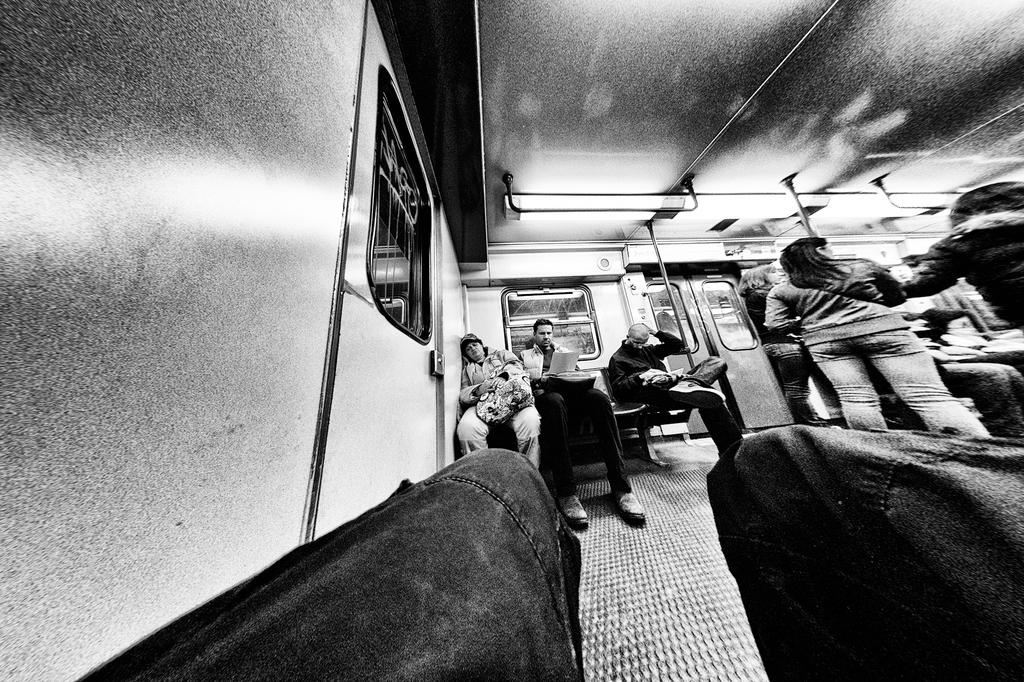What is the color scheme of the image? The image is black and white. What can be seen inside the vehicle in the image? There are people standing and sitting inside the vehicle. What is one feature of the vehicle that allows for entry or exit? There is a door visible in the image. How can the people inside the vehicle see their surroundings? There are windows in the vehicle. Can you see any goldfish swimming in the image? There are no goldfish present in the image. Is anyone blowing bubbles in the image? There is no indication of anyone blowing bubbles in the image. 